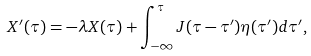<formula> <loc_0><loc_0><loc_500><loc_500>X ^ { \prime } ( \tau ) = - { \lambda } X ( \tau ) + \int _ { - \infty } ^ { \tau } J ( \tau - \tau ^ { \prime } ) \eta ( \tau ^ { \prime } ) d \tau ^ { \prime } ,</formula> 